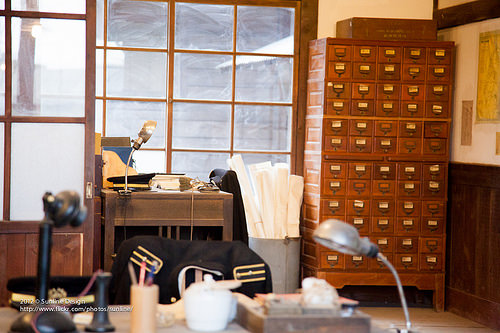<image>
Is the lamp in front of the cabinet? Yes. The lamp is positioned in front of the cabinet, appearing closer to the camera viewpoint. 